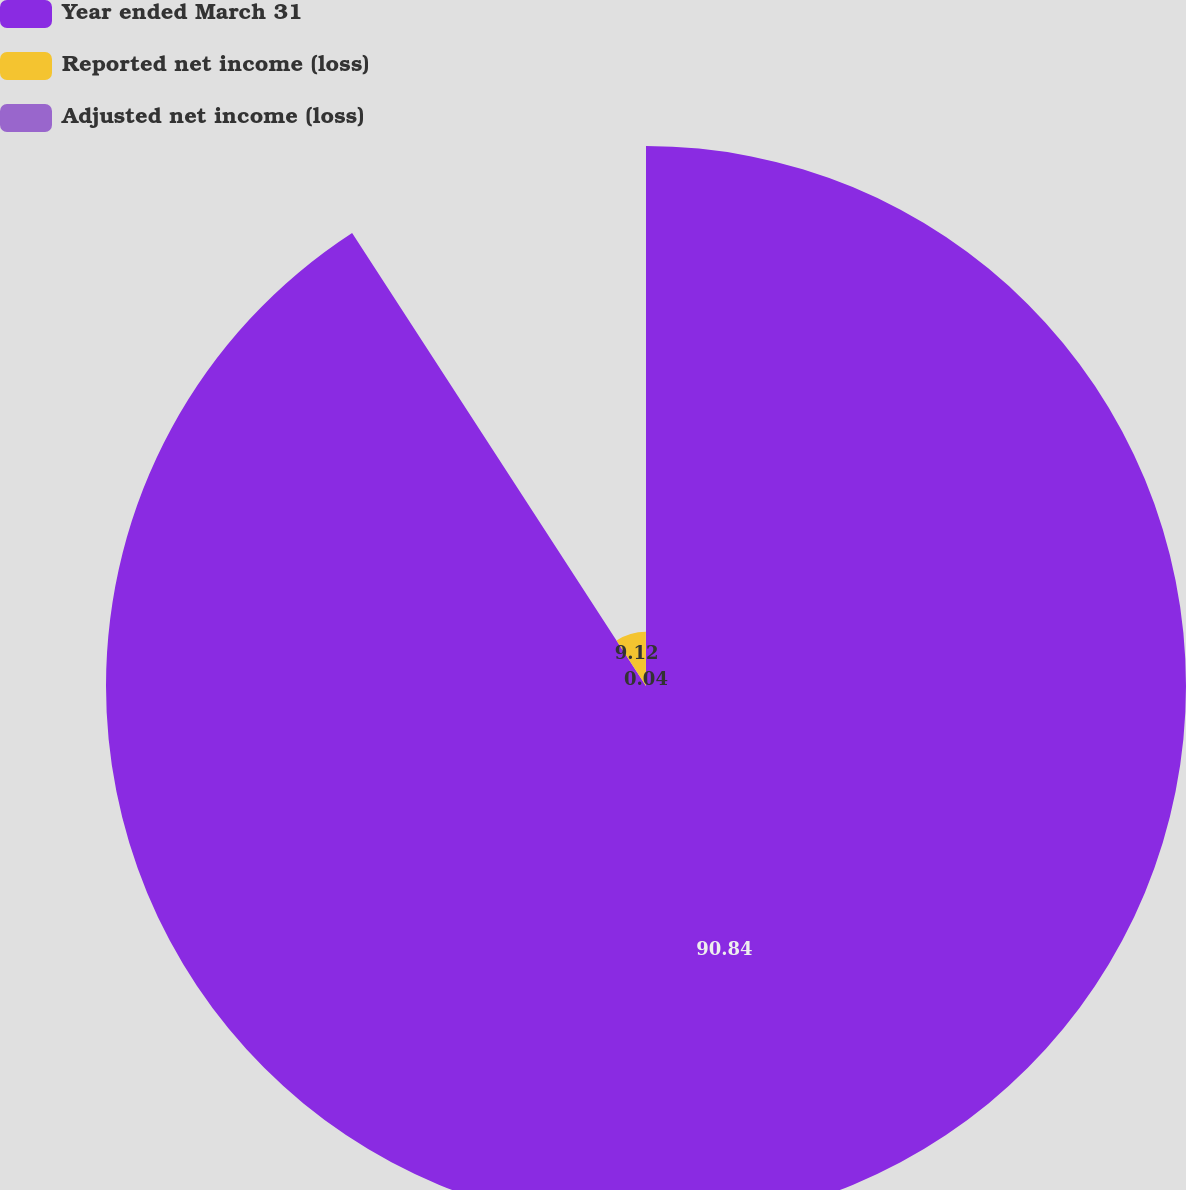Convert chart. <chart><loc_0><loc_0><loc_500><loc_500><pie_chart><fcel>Year ended March 31<fcel>Reported net income (loss)<fcel>Adjusted net income (loss)<nl><fcel>90.85%<fcel>9.12%<fcel>0.04%<nl></chart> 